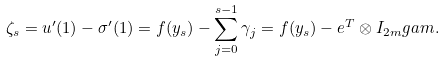<formula> <loc_0><loc_0><loc_500><loc_500>\zeta _ { s } = u ^ { \prime } ( 1 ) - \sigma ^ { \prime } ( 1 ) = f ( y _ { s } ) - \sum _ { j = 0 } ^ { s - 1 } \gamma _ { j } = f ( y _ { s } ) - { e } ^ { T } \otimes I _ { 2 m } g a m .</formula> 